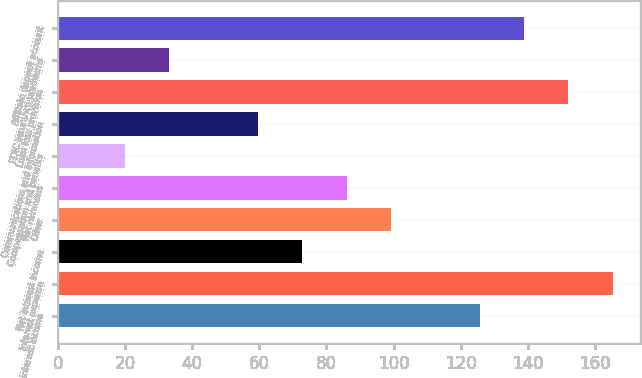<chart> <loc_0><loc_0><loc_500><loc_500><bar_chart><fcel>Interest income<fcel>Interest expense<fcel>Net interest income<fcel>Other<fcel>Net revenues<fcel>Compensation and benefits<fcel>Communications and information<fcel>Loan loss provision<fcel>FDIC insurance premiums<fcel>Affiliate deposit account<nl><fcel>125.6<fcel>165.2<fcel>72.8<fcel>99.2<fcel>86<fcel>20<fcel>59.6<fcel>152<fcel>33.2<fcel>138.8<nl></chart> 